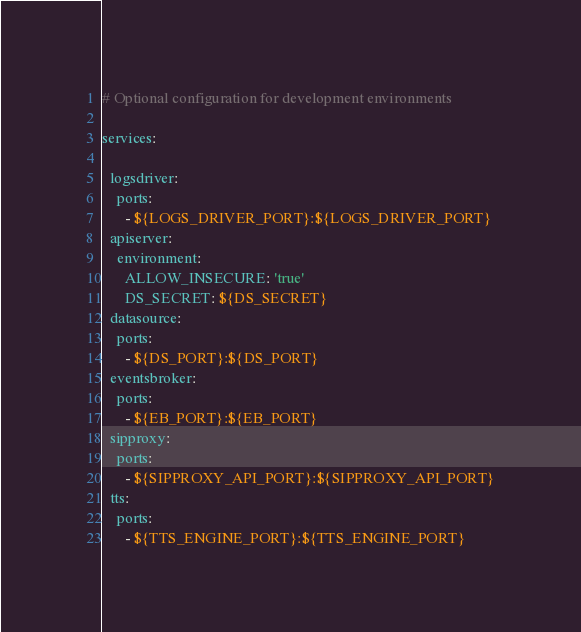Convert code to text. <code><loc_0><loc_0><loc_500><loc_500><_YAML_># Optional configuration for development environments

services:

  logsdriver:
    ports:
      - ${LOGS_DRIVER_PORT}:${LOGS_DRIVER_PORT}
  apiserver:
    environment:
      ALLOW_INSECURE: 'true'
      DS_SECRET: ${DS_SECRET}
  datasource:
    ports:
      - ${DS_PORT}:${DS_PORT}
  eventsbroker:
    ports:
      - ${EB_PORT}:${EB_PORT}
  sipproxy:
    ports:
      - ${SIPPROXY_API_PORT}:${SIPPROXY_API_PORT}
  tts:
    ports:
      - ${TTS_ENGINE_PORT}:${TTS_ENGINE_PORT}
</code> 